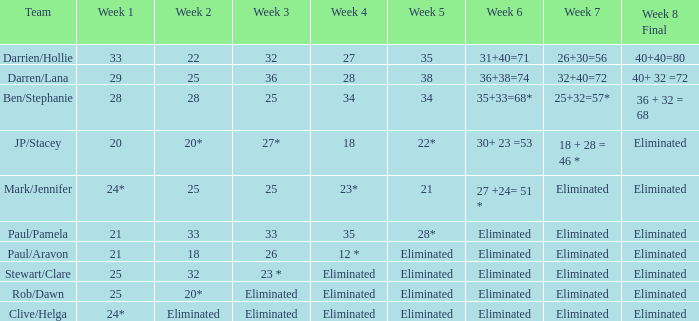Name the week 3 of 36 29.0. 